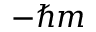Convert formula to latex. <formula><loc_0><loc_0><loc_500><loc_500>- \hbar { m }</formula> 